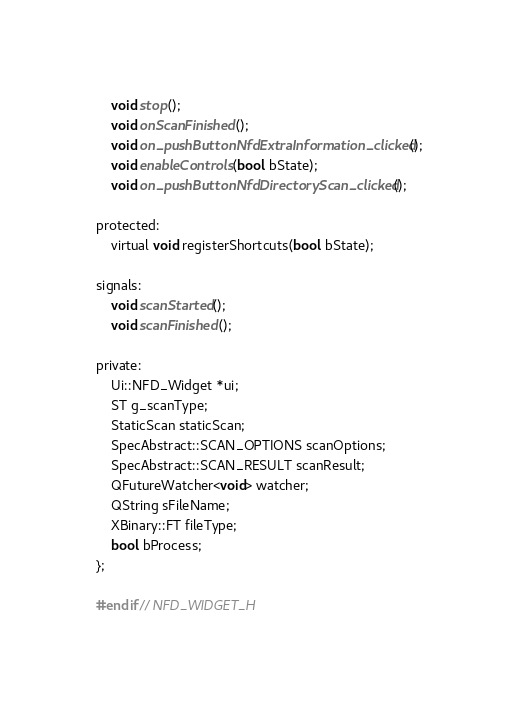Convert code to text. <code><loc_0><loc_0><loc_500><loc_500><_C_>    void stop();
    void onScanFinished();
    void on_pushButtonNfdExtraInformation_clicked();
    void enableControls(bool bState);
    void on_pushButtonNfdDirectoryScan_clicked();

protected:
    virtual void registerShortcuts(bool bState);

signals:
    void scanStarted();
    void scanFinished();

private:
    Ui::NFD_Widget *ui;
    ST g_scanType;
    StaticScan staticScan;
    SpecAbstract::SCAN_OPTIONS scanOptions;
    SpecAbstract::SCAN_RESULT scanResult;
    QFutureWatcher<void> watcher;
    QString sFileName;
    XBinary::FT fileType;
    bool bProcess;
};

#endif // NFD_WIDGET_H
</code> 